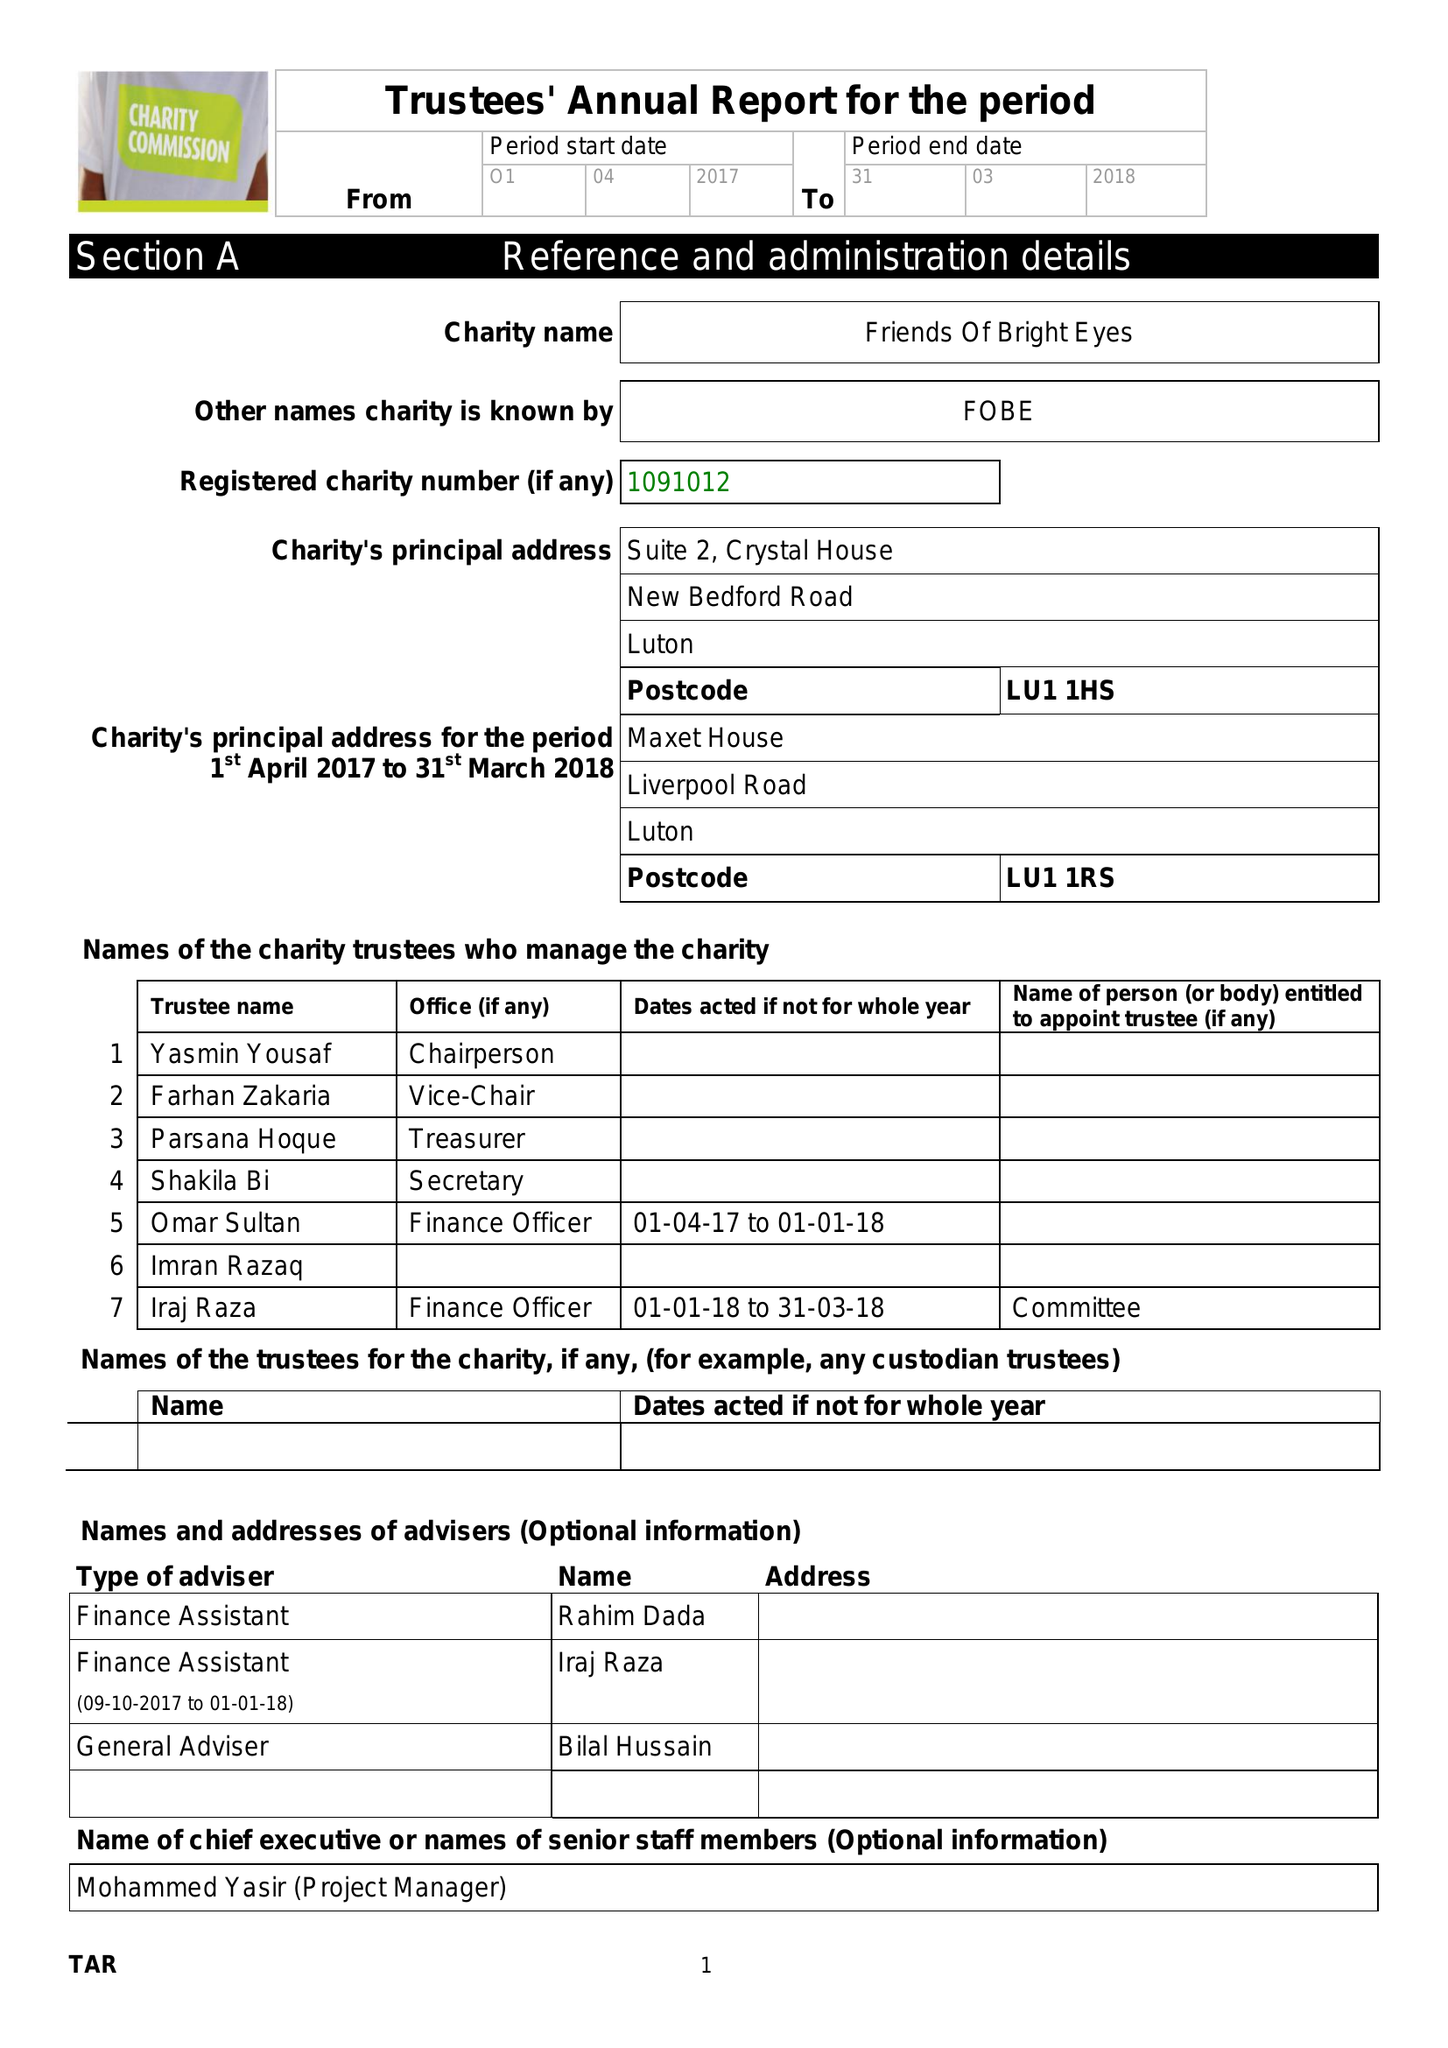What is the value for the charity_name?
Answer the question using a single word or phrase. Friends Of Bright Eyes 